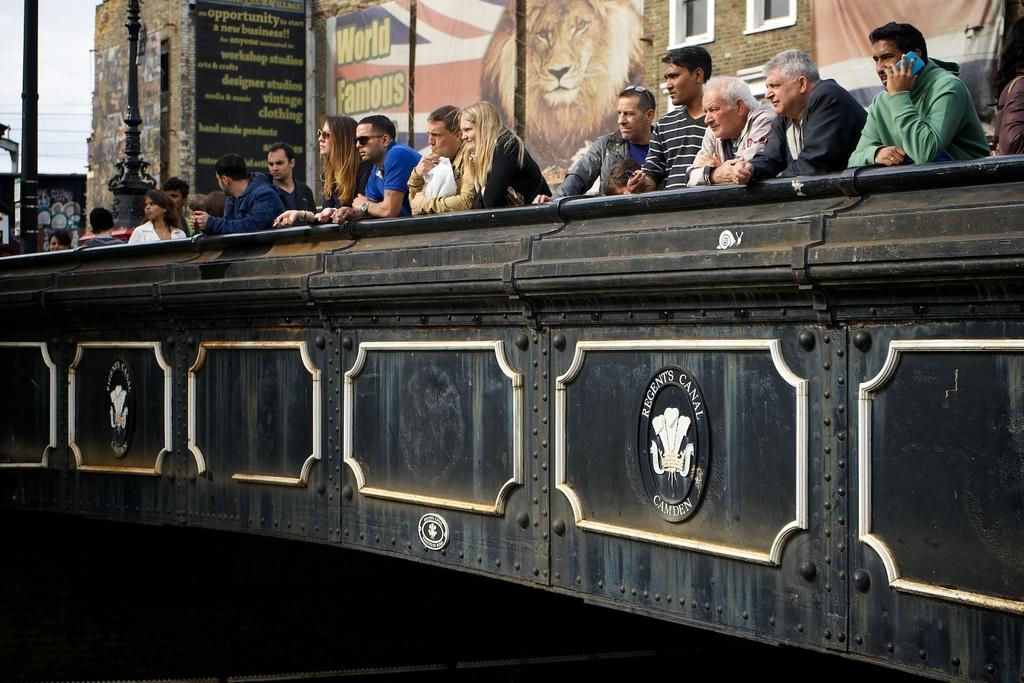<image>
Write a terse but informative summary of the picture. People lean on a wall that has a circle with Regent's canal Camden. 